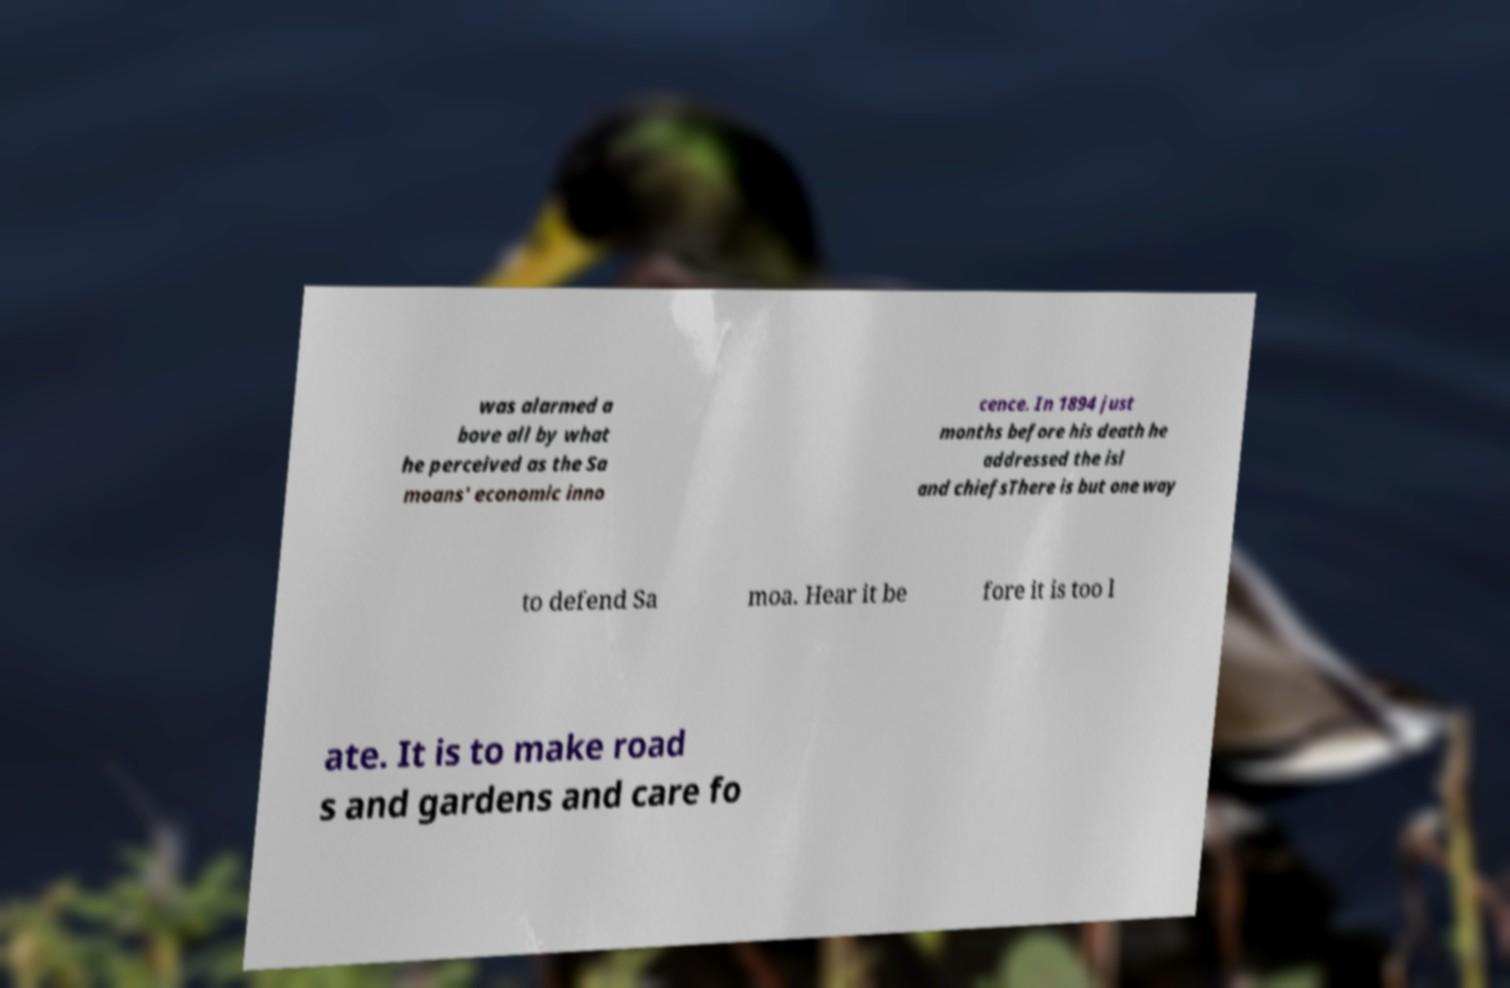What messages or text are displayed in this image? I need them in a readable, typed format. was alarmed a bove all by what he perceived as the Sa moans' economic inno cence. In 1894 just months before his death he addressed the isl and chiefsThere is but one way to defend Sa moa. Hear it be fore it is too l ate. It is to make road s and gardens and care fo 